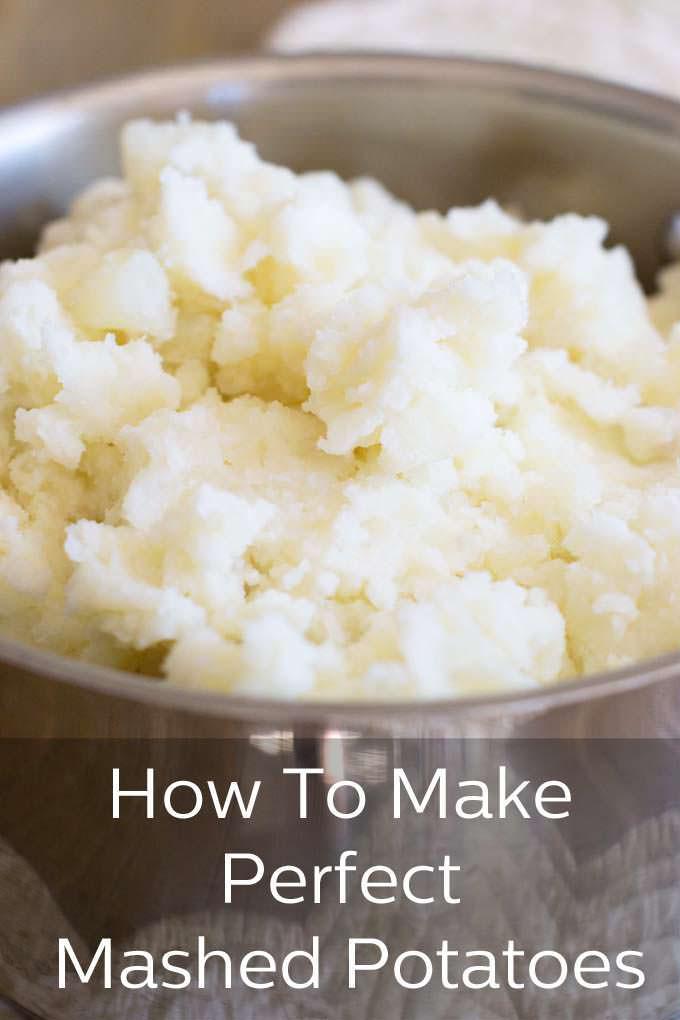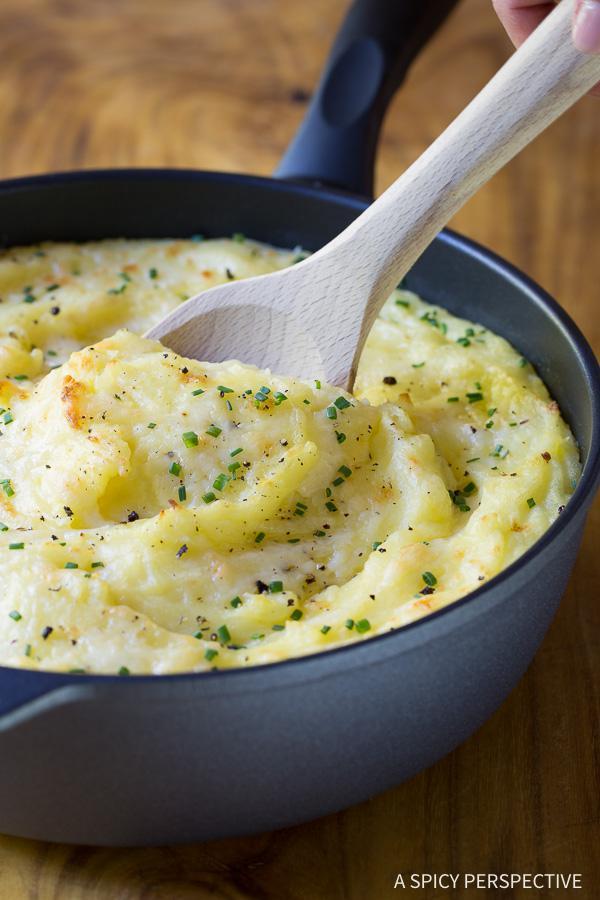The first image is the image on the left, the second image is the image on the right. Analyze the images presented: Is the assertion "The left image shows mashed potatoes in an oblong white bowl with cut-out handles." valid? Answer yes or no. No. 